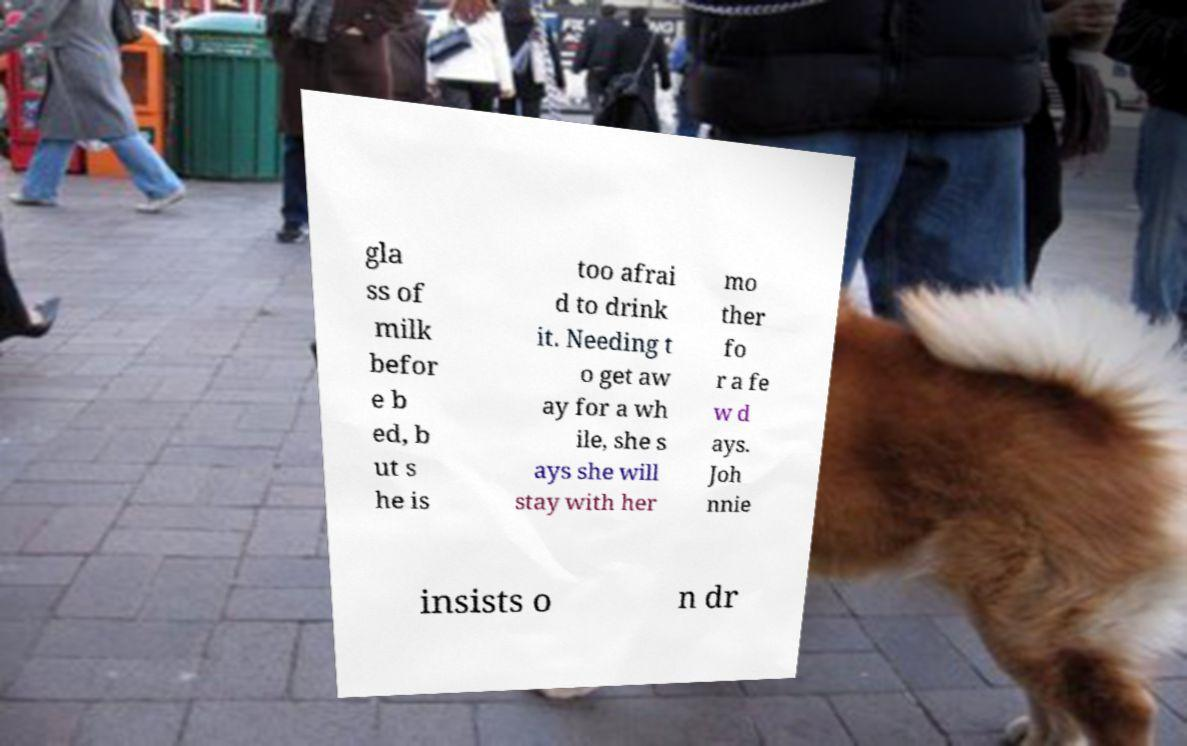There's text embedded in this image that I need extracted. Can you transcribe it verbatim? gla ss of milk befor e b ed, b ut s he is too afrai d to drink it. Needing t o get aw ay for a wh ile, she s ays she will stay with her mo ther fo r a fe w d ays. Joh nnie insists o n dr 